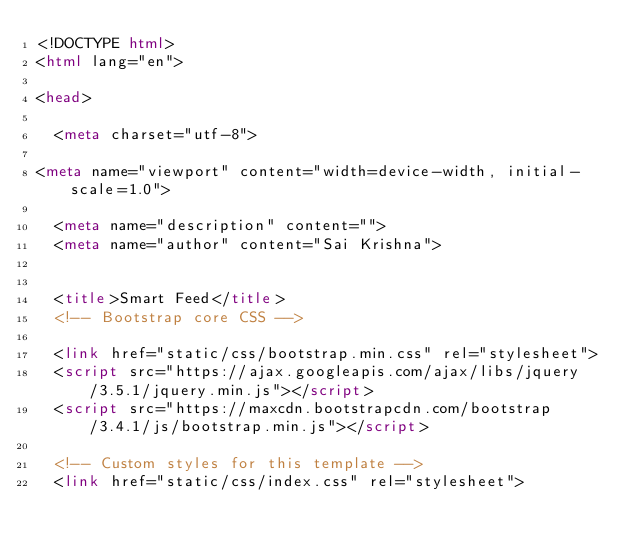Convert code to text. <code><loc_0><loc_0><loc_500><loc_500><_HTML_><!DOCTYPE html>
<html lang="en">

<head>

  <meta charset="utf-8">
 
<meta name="viewport" content="width=device-width, initial-scale=1.0">

  <meta name="description" content="">
  <meta name="author" content="Sai Krishna">


  <title>Smart Feed</title>
  <!-- Bootstrap core CSS -->

  <link href="static/css/bootstrap.min.css" rel="stylesheet">
  <script src="https://ajax.googleapis.com/ajax/libs/jquery/3.5.1/jquery.min.js"></script>
  <script src="https://maxcdn.bootstrapcdn.com/bootstrap/3.4.1/js/bootstrap.min.js"></script>

  <!-- Custom styles for this template -->
  <link href="static/css/index.css" rel="stylesheet"></code> 